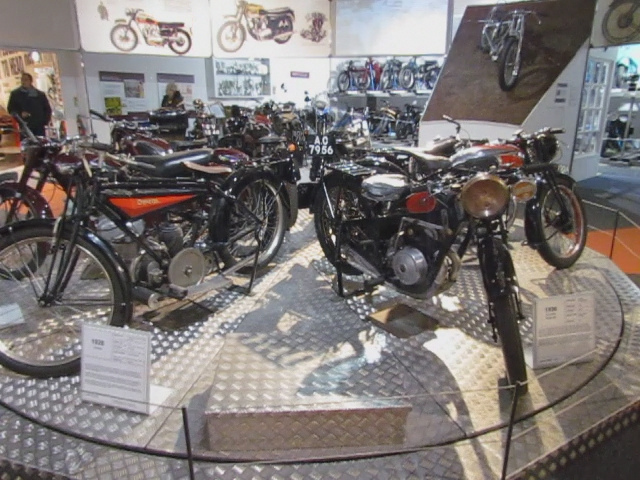Could you explain the significance of the different designs seen in these motorcycles? Each motorcycle's design reflects the needs, aesthetic preferences, and technological innovations of the time it was created. Variations in body shape, engine size, and additional features tell a story of adapting to market demands, advances in materials and mechanics, as well as changing cultural influences on the perception of mobility and freedom. 